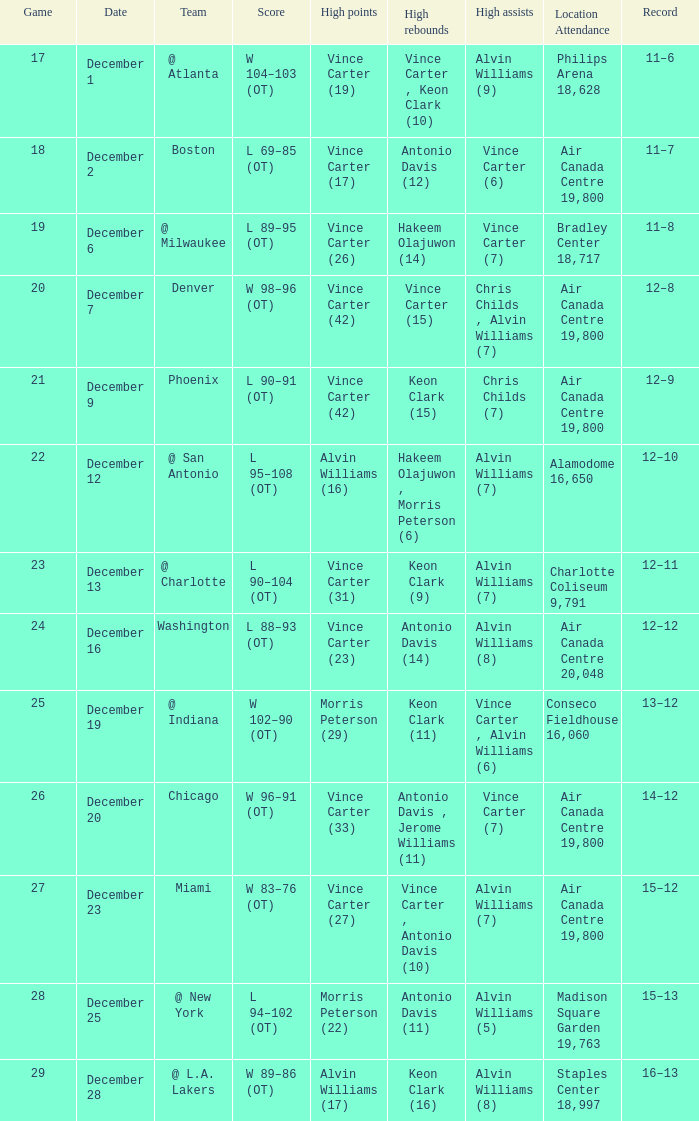Who holds the record for the highest points scored against washington? Vince Carter (23). 